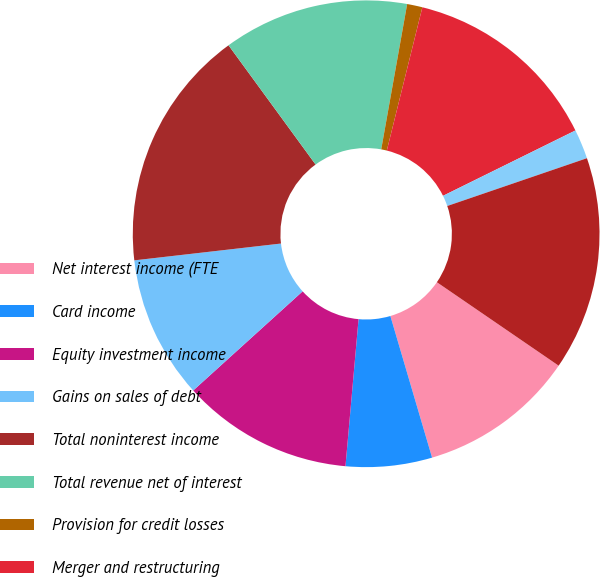Convert chart. <chart><loc_0><loc_0><loc_500><loc_500><pie_chart><fcel>Net interest income (FTE<fcel>Card income<fcel>Equity investment income<fcel>Gains on sales of debt<fcel>Total noninterest income<fcel>Total revenue net of interest<fcel>Provision for credit losses<fcel>Merger and restructuring<fcel>All other noninterest expense<fcel>Income tax benefit (FTE basis)<nl><fcel>10.88%<fcel>5.97%<fcel>11.87%<fcel>9.9%<fcel>16.78%<fcel>12.85%<fcel>1.06%<fcel>13.83%<fcel>2.05%<fcel>14.81%<nl></chart> 